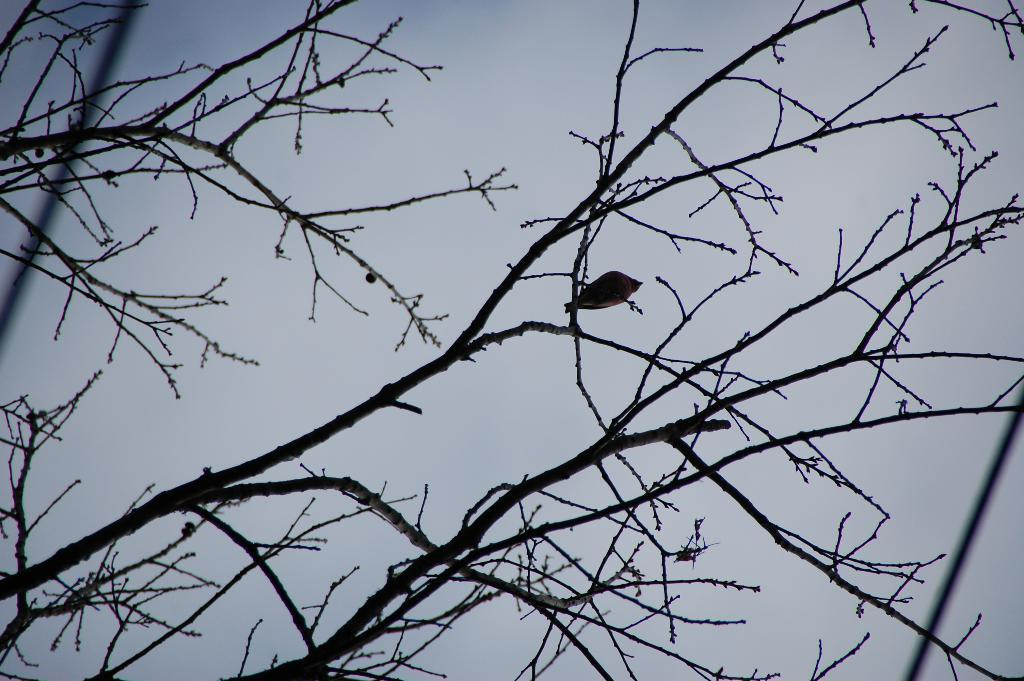What is the condition of the tree in the image? The tree in the image is dry. Is there any wildlife present in the image? Yes, there is a bird sitting on the tree. What can be seen in the background of the image? The sky is visible in the image. Where is the toothbrush located in the image? There is no toothbrush present in the image. What type of camera is being used to take the picture of the tree and bird? The facts provided do not mention a camera, so it is not possible to determine what type of camera is being used. 